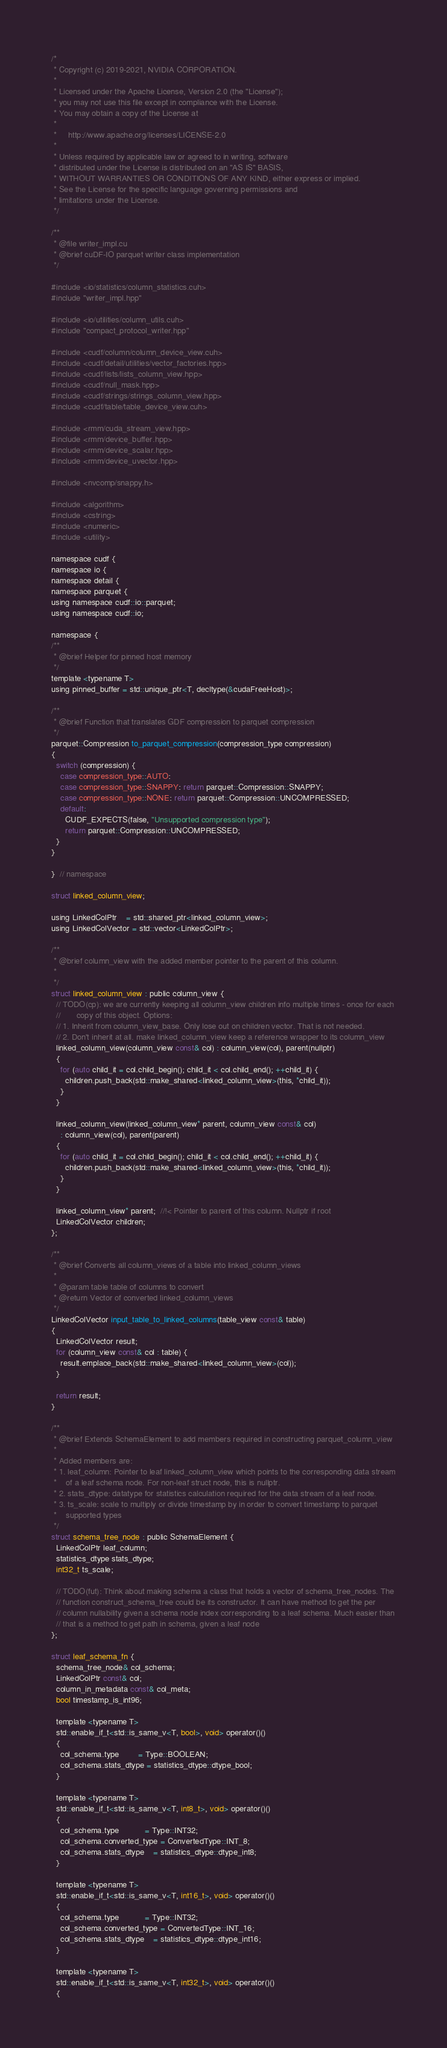Convert code to text. <code><loc_0><loc_0><loc_500><loc_500><_Cuda_>/*
 * Copyright (c) 2019-2021, NVIDIA CORPORATION.
 *
 * Licensed under the Apache License, Version 2.0 (the "License");
 * you may not use this file except in compliance with the License.
 * You may obtain a copy of the License at
 *
 *     http://www.apache.org/licenses/LICENSE-2.0
 *
 * Unless required by applicable law or agreed to in writing, software
 * distributed under the License is distributed on an "AS IS" BASIS,
 * WITHOUT WARRANTIES OR CONDITIONS OF ANY KIND, either express or implied.
 * See the License for the specific language governing permissions and
 * limitations under the License.
 */

/**
 * @file writer_impl.cu
 * @brief cuDF-IO parquet writer class implementation
 */

#include <io/statistics/column_statistics.cuh>
#include "writer_impl.hpp"

#include <io/utilities/column_utils.cuh>
#include "compact_protocol_writer.hpp"

#include <cudf/column/column_device_view.cuh>
#include <cudf/detail/utilities/vector_factories.hpp>
#include <cudf/lists/lists_column_view.hpp>
#include <cudf/null_mask.hpp>
#include <cudf/strings/strings_column_view.hpp>
#include <cudf/table/table_device_view.cuh>

#include <rmm/cuda_stream_view.hpp>
#include <rmm/device_buffer.hpp>
#include <rmm/device_scalar.hpp>
#include <rmm/device_uvector.hpp>

#include <nvcomp/snappy.h>

#include <algorithm>
#include <cstring>
#include <numeric>
#include <utility>

namespace cudf {
namespace io {
namespace detail {
namespace parquet {
using namespace cudf::io::parquet;
using namespace cudf::io;

namespace {
/**
 * @brief Helper for pinned host memory
 */
template <typename T>
using pinned_buffer = std::unique_ptr<T, decltype(&cudaFreeHost)>;

/**
 * @brief Function that translates GDF compression to parquet compression
 */
parquet::Compression to_parquet_compression(compression_type compression)
{
  switch (compression) {
    case compression_type::AUTO:
    case compression_type::SNAPPY: return parquet::Compression::SNAPPY;
    case compression_type::NONE: return parquet::Compression::UNCOMPRESSED;
    default:
      CUDF_EXPECTS(false, "Unsupported compression type");
      return parquet::Compression::UNCOMPRESSED;
  }
}

}  // namespace

struct linked_column_view;

using LinkedColPtr    = std::shared_ptr<linked_column_view>;
using LinkedColVector = std::vector<LinkedColPtr>;

/**
 * @brief column_view with the added member pointer to the parent of this column.
 *
 */
struct linked_column_view : public column_view {
  // TODO(cp): we are currently keeping all column_view children info multiple times - once for each
  //       copy of this object. Options:
  // 1. Inherit from column_view_base. Only lose out on children vector. That is not needed.
  // 2. Don't inherit at all. make linked_column_view keep a reference wrapper to its column_view
  linked_column_view(column_view const& col) : column_view(col), parent(nullptr)
  {
    for (auto child_it = col.child_begin(); child_it < col.child_end(); ++child_it) {
      children.push_back(std::make_shared<linked_column_view>(this, *child_it));
    }
  }

  linked_column_view(linked_column_view* parent, column_view const& col)
    : column_view(col), parent(parent)
  {
    for (auto child_it = col.child_begin(); child_it < col.child_end(); ++child_it) {
      children.push_back(std::make_shared<linked_column_view>(this, *child_it));
    }
  }

  linked_column_view* parent;  //!< Pointer to parent of this column. Nullptr if root
  LinkedColVector children;
};

/**
 * @brief Converts all column_views of a table into linked_column_views
 *
 * @param table table of columns to convert
 * @return Vector of converted linked_column_views
 */
LinkedColVector input_table_to_linked_columns(table_view const& table)
{
  LinkedColVector result;
  for (column_view const& col : table) {
    result.emplace_back(std::make_shared<linked_column_view>(col));
  }

  return result;
}

/**
 * @brief Extends SchemaElement to add members required in constructing parquet_column_view
 *
 * Added members are:
 * 1. leaf_column: Pointer to leaf linked_column_view which points to the corresponding data stream
 *    of a leaf schema node. For non-leaf struct node, this is nullptr.
 * 2. stats_dtype: datatype for statistics calculation required for the data stream of a leaf node.
 * 3. ts_scale: scale to multiply or divide timestamp by in order to convert timestamp to parquet
 *    supported types
 */
struct schema_tree_node : public SchemaElement {
  LinkedColPtr leaf_column;
  statistics_dtype stats_dtype;
  int32_t ts_scale;

  // TODO(fut): Think about making schema a class that holds a vector of schema_tree_nodes. The
  // function construct_schema_tree could be its constructor. It can have method to get the per
  // column nullability given a schema node index corresponding to a leaf schema. Much easier than
  // that is a method to get path in schema, given a leaf node
};

struct leaf_schema_fn {
  schema_tree_node& col_schema;
  LinkedColPtr const& col;
  column_in_metadata const& col_meta;
  bool timestamp_is_int96;

  template <typename T>
  std::enable_if_t<std::is_same_v<T, bool>, void> operator()()
  {
    col_schema.type        = Type::BOOLEAN;
    col_schema.stats_dtype = statistics_dtype::dtype_bool;
  }

  template <typename T>
  std::enable_if_t<std::is_same_v<T, int8_t>, void> operator()()
  {
    col_schema.type           = Type::INT32;
    col_schema.converted_type = ConvertedType::INT_8;
    col_schema.stats_dtype    = statistics_dtype::dtype_int8;
  }

  template <typename T>
  std::enable_if_t<std::is_same_v<T, int16_t>, void> operator()()
  {
    col_schema.type           = Type::INT32;
    col_schema.converted_type = ConvertedType::INT_16;
    col_schema.stats_dtype    = statistics_dtype::dtype_int16;
  }

  template <typename T>
  std::enable_if_t<std::is_same_v<T, int32_t>, void> operator()()
  {</code> 